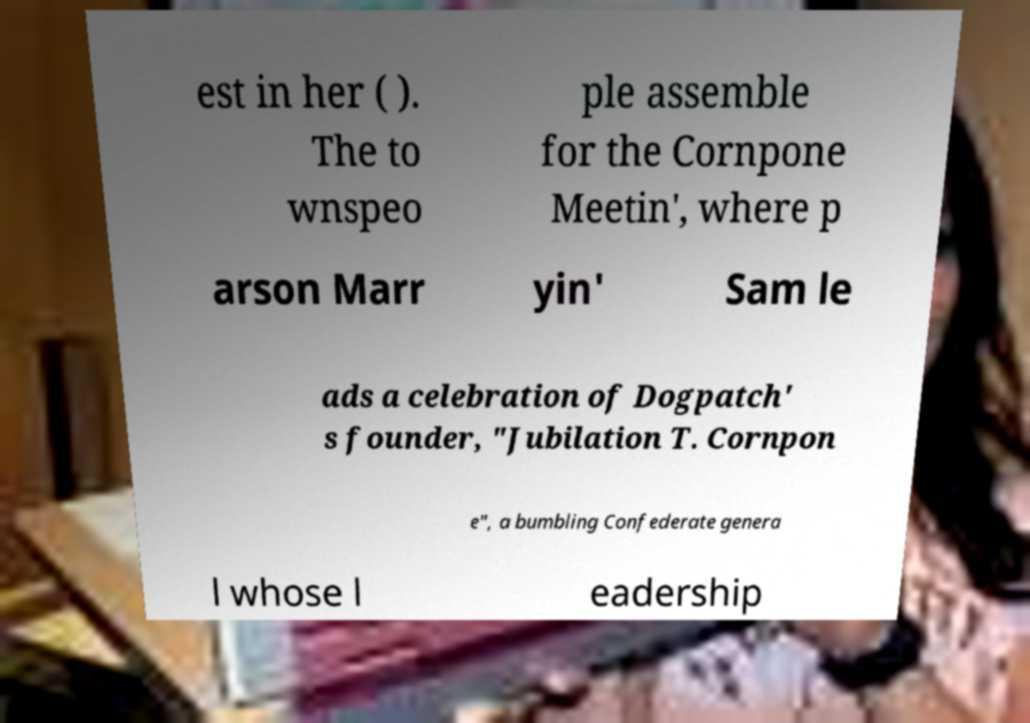What messages or text are displayed in this image? I need them in a readable, typed format. est in her ( ). The to wnspeo ple assemble for the Cornpone Meetin', where p arson Marr yin' Sam le ads a celebration of Dogpatch' s founder, "Jubilation T. Cornpon e", a bumbling Confederate genera l whose l eadership 